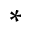Convert formula to latex. <formula><loc_0><loc_0><loc_500><loc_500>\ast</formula> 